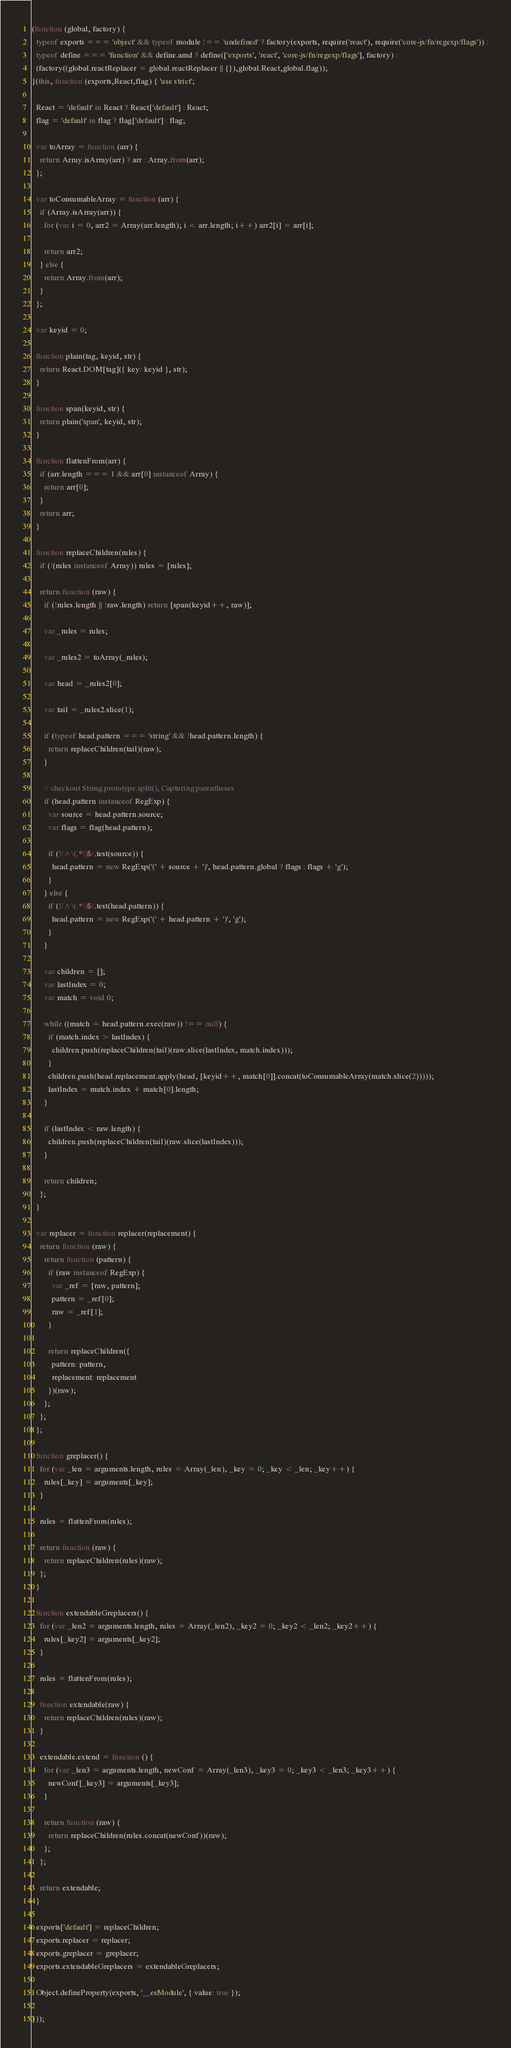Convert code to text. <code><loc_0><loc_0><loc_500><loc_500><_JavaScript_>(function (global, factory) {
  typeof exports === 'object' && typeof module !== 'undefined' ? factory(exports, require('react'), require('core-js/fn/regexp/flags')) :
  typeof define === 'function' && define.amd ? define(['exports', 'react', 'core-js/fn/regexp/flags'], factory) :
  (factory((global.reactReplacer = global.reactReplacer || {}),global.React,global.flag));
}(this, function (exports,React,flag) { 'use strict';

  React = 'default' in React ? React['default'] : React;
  flag = 'default' in flag ? flag['default'] : flag;

  var toArray = function (arr) {
    return Array.isArray(arr) ? arr : Array.from(arr);
  };

  var toConsumableArray = function (arr) {
    if (Array.isArray(arr)) {
      for (var i = 0, arr2 = Array(arr.length); i < arr.length; i++) arr2[i] = arr[i];

      return arr2;
    } else {
      return Array.from(arr);
    }
  };

  var keyid = 0;

  function plain(tag, keyid, str) {
    return React.DOM[tag]({ key: keyid }, str);
  }

  function span(keyid, str) {
    return plain('span', keyid, str);
  }

  function flattenFrom(arr) {
    if (arr.length === 1 && arr[0] instanceof Array) {
      return arr[0];
    }
    return arr;
  }

  function replaceChildren(rules) {
    if (!(rules instanceof Array)) rules = [rules];

    return function (raw) {
      if (!rules.length || !raw.length) return [span(keyid++, raw)];

      var _rules = rules;

      var _rules2 = toArray(_rules);

      var head = _rules2[0];

      var tail = _rules2.slice(1);

      if (typeof head.pattern === 'string' && !head.pattern.length) {
        return replaceChildren(tail)(raw);
      }

      // checkout String.prototype.split(), Capturing parentheses
      if (head.pattern instanceof RegExp) {
        var source = head.pattern.source;
        var flags = flag(head.pattern);

        if (!/^\(.*\)$/.test(source)) {
          head.pattern = new RegExp('(' + source + ')', head.pattern.global ? flags : flags + 'g');
        }
      } else {
        if (!/^\(.*\)$/.test(head.pattern)) {
          head.pattern = new RegExp('(' + head.pattern + ')', 'g');
        }
      }

      var children = [];
      var lastIndex = 0;
      var match = void 0;

      while ((match = head.pattern.exec(raw)) !== null) {
        if (match.index > lastIndex) {
          children.push(replaceChildren(tail)(raw.slice(lastIndex, match.index)));
        }
        children.push(head.replacement.apply(head, [keyid++, match[0]].concat(toConsumableArray(match.slice(2)))));
        lastIndex = match.index + match[0].length;
      }

      if (lastIndex < raw.length) {
        children.push(replaceChildren(tail)(raw.slice(lastIndex)));
      }

      return children;
    };
  }

  var replacer = function replacer(replacement) {
    return function (raw) {
      return function (pattern) {
        if (raw instanceof RegExp) {
          var _ref = [raw, pattern];
          pattern = _ref[0];
          raw = _ref[1];
        }

        return replaceChildren({
          pattern: pattern,
          replacement: replacement
        })(raw);
      };
    };
  };

  function greplacer() {
    for (var _len = arguments.length, rules = Array(_len), _key = 0; _key < _len; _key++) {
      rules[_key] = arguments[_key];
    }

    rules = flattenFrom(rules);

    return function (raw) {
      return replaceChildren(rules)(raw);
    };
  }

  function extendableGreplacers() {
    for (var _len2 = arguments.length, rules = Array(_len2), _key2 = 0; _key2 < _len2; _key2++) {
      rules[_key2] = arguments[_key2];
    }

    rules = flattenFrom(rules);

    function extendable(raw) {
      return replaceChildren(rules)(raw);
    }

    extendable.extend = function () {
      for (var _len3 = arguments.length, newConf = Array(_len3), _key3 = 0; _key3 < _len3; _key3++) {
        newConf[_key3] = arguments[_key3];
      }

      return function (raw) {
        return replaceChildren(rules.concat(newConf))(raw);
      };
    };

    return extendable;
  }

  exports['default'] = replaceChildren;
  exports.replacer = replacer;
  exports.greplacer = greplacer;
  exports.extendableGreplacers = extendableGreplacers;

  Object.defineProperty(exports, '__esModule', { value: true });

}));</code> 